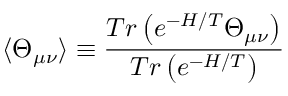<formula> <loc_0><loc_0><loc_500><loc_500>\langle \Theta _ { \mu \nu } \rangle \equiv \frac { T r \left ( e ^ { - H / T } \Theta _ { \mu \nu } \right ) } { T r \left ( e ^ { - H / T } \right ) }</formula> 